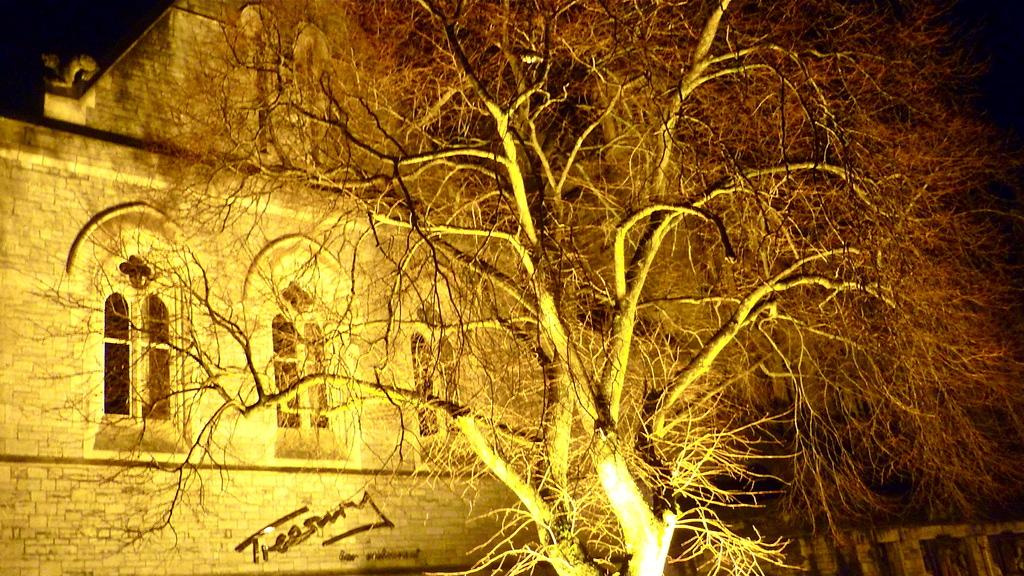What type of building is visible in the image? There is a building with glass windows in the image. What can be seen on the building wall? There is text on the building wall. Are there any lighting features attached to the building? Yes, there are lights attached to the building. What type of vegetation is present in the image? There is a big tree in the image. What architectural feature can be seen in the image? There is a wall with pillars in the image. What type of needle is used to sew the text on the building wall? There is no needle present in the image, and the text on the building wall is not sewn. 